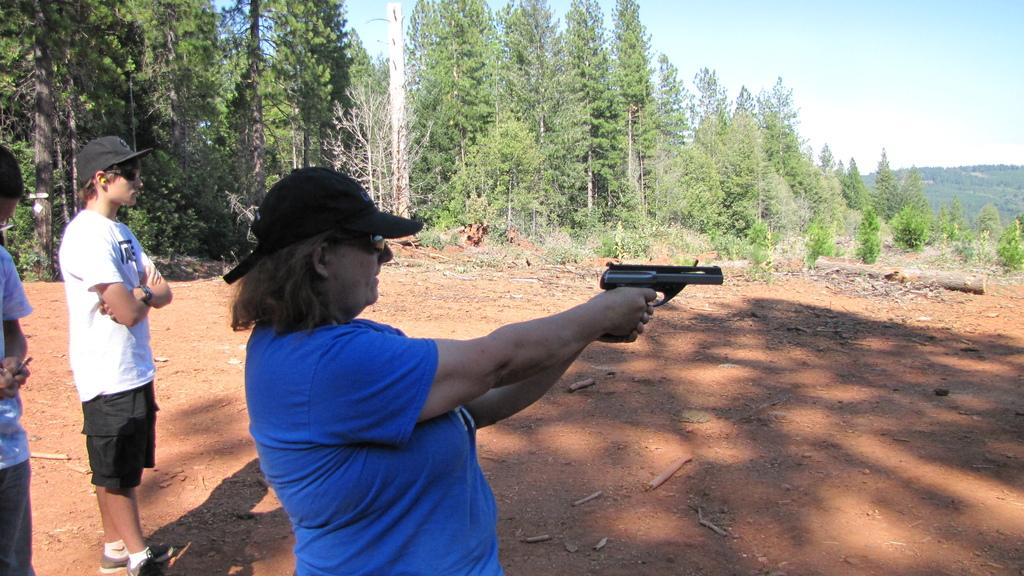What is the person in the image holding? The person is holding a gun in the image. How many other people are present in the image? There are two other persons standing in the image. What type of vegetation can be seen in the image? Plants and trees are visible in the image. What is visible at the top of the image? The sky is visible at the top of the image. Where is the marble located in the image? There is no marble present in the image. What type of store can be seen in the background of the image? There is no store visible in the image. 